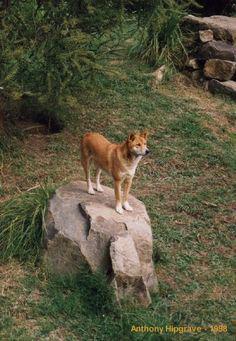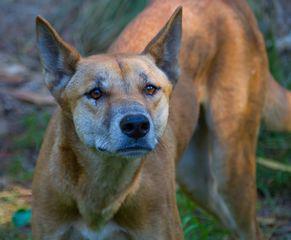The first image is the image on the left, the second image is the image on the right. Analyze the images presented: Is the assertion "There is only one dog in each picture." valid? Answer yes or no. Yes. The first image is the image on the left, the second image is the image on the right. Evaluate the accuracy of this statement regarding the images: "The fox in the image on the left is standing in a barren sandy area.". Is it true? Answer yes or no. No. 